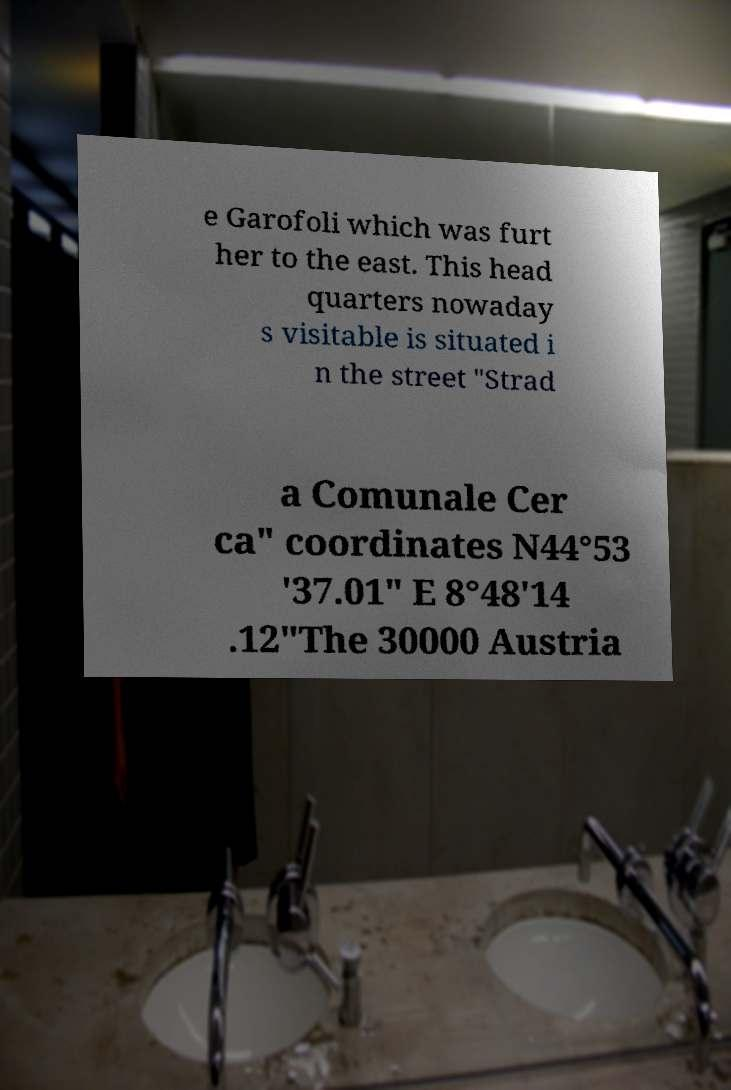Could you extract and type out the text from this image? e Garofoli which was furt her to the east. This head quarters nowaday s visitable is situated i n the street "Strad a Comunale Cer ca" coordinates N44°53 '37.01" E 8°48'14 .12"The 30000 Austria 